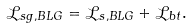Convert formula to latex. <formula><loc_0><loc_0><loc_500><loc_500>\mathcal { L } _ { s g , B L G } = \mathcal { L } _ { s , B L G } + \mathcal { L } _ { b t } .</formula> 